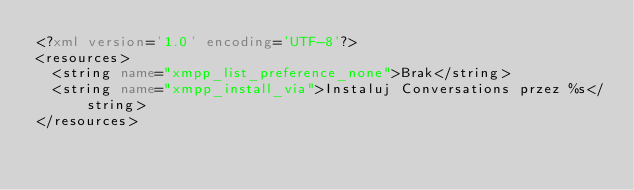<code> <loc_0><loc_0><loc_500><loc_500><_XML_><?xml version='1.0' encoding='UTF-8'?>
<resources>
  <string name="xmpp_list_preference_none">Brak</string>
  <string name="xmpp_install_via">Instaluj Conversations przez %s</string>
</resources>
</code> 